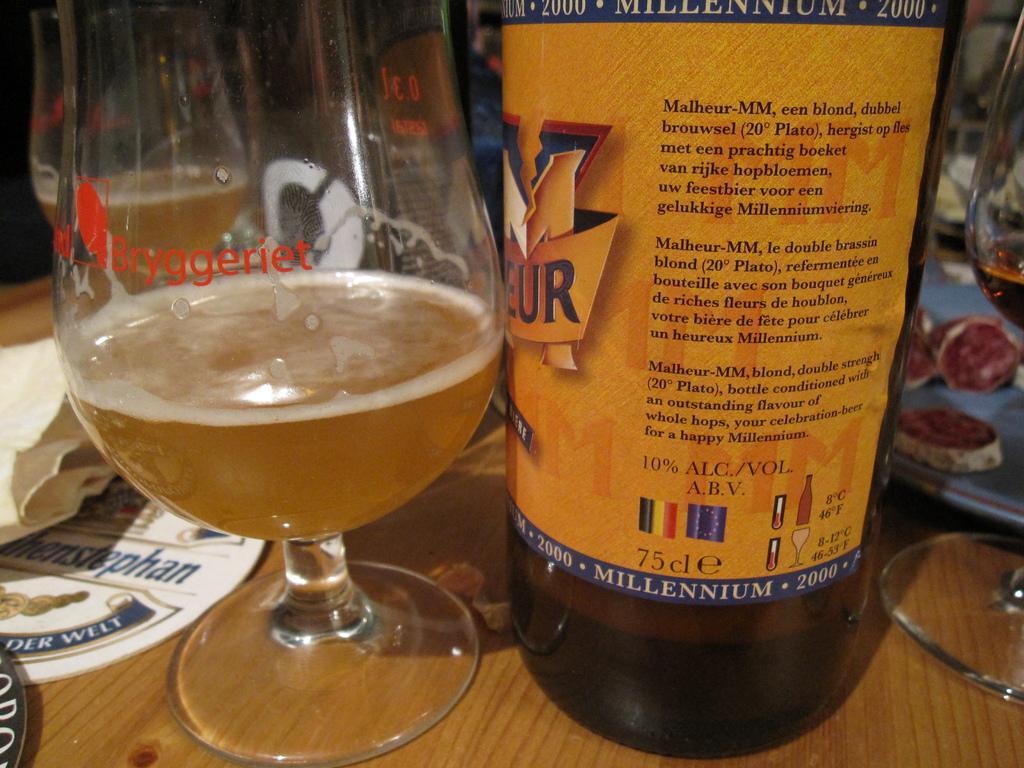Please provide a concise description of this image. In this image we can see bottle and a glass on the table. 